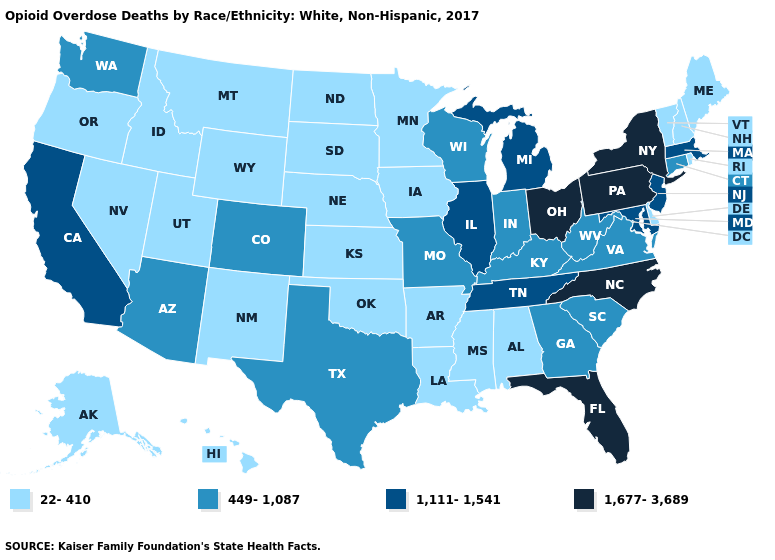Name the states that have a value in the range 1,677-3,689?
Quick response, please. Florida, New York, North Carolina, Ohio, Pennsylvania. What is the value of Massachusetts?
Keep it brief. 1,111-1,541. What is the lowest value in the USA?
Write a very short answer. 22-410. Name the states that have a value in the range 1,111-1,541?
Quick response, please. California, Illinois, Maryland, Massachusetts, Michigan, New Jersey, Tennessee. Name the states that have a value in the range 449-1,087?
Keep it brief. Arizona, Colorado, Connecticut, Georgia, Indiana, Kentucky, Missouri, South Carolina, Texas, Virginia, Washington, West Virginia, Wisconsin. What is the lowest value in the USA?
Be succinct. 22-410. Which states have the lowest value in the MidWest?
Give a very brief answer. Iowa, Kansas, Minnesota, Nebraska, North Dakota, South Dakota. Name the states that have a value in the range 1,677-3,689?
Keep it brief. Florida, New York, North Carolina, Ohio, Pennsylvania. Does Mississippi have the same value as Maine?
Keep it brief. Yes. Name the states that have a value in the range 449-1,087?
Short answer required. Arizona, Colorado, Connecticut, Georgia, Indiana, Kentucky, Missouri, South Carolina, Texas, Virginia, Washington, West Virginia, Wisconsin. What is the lowest value in states that border Alabama?
Keep it brief. 22-410. What is the highest value in states that border Michigan?
Keep it brief. 1,677-3,689. Is the legend a continuous bar?
Give a very brief answer. No. What is the value of Arizona?
Concise answer only. 449-1,087. Name the states that have a value in the range 1,677-3,689?
Give a very brief answer. Florida, New York, North Carolina, Ohio, Pennsylvania. 